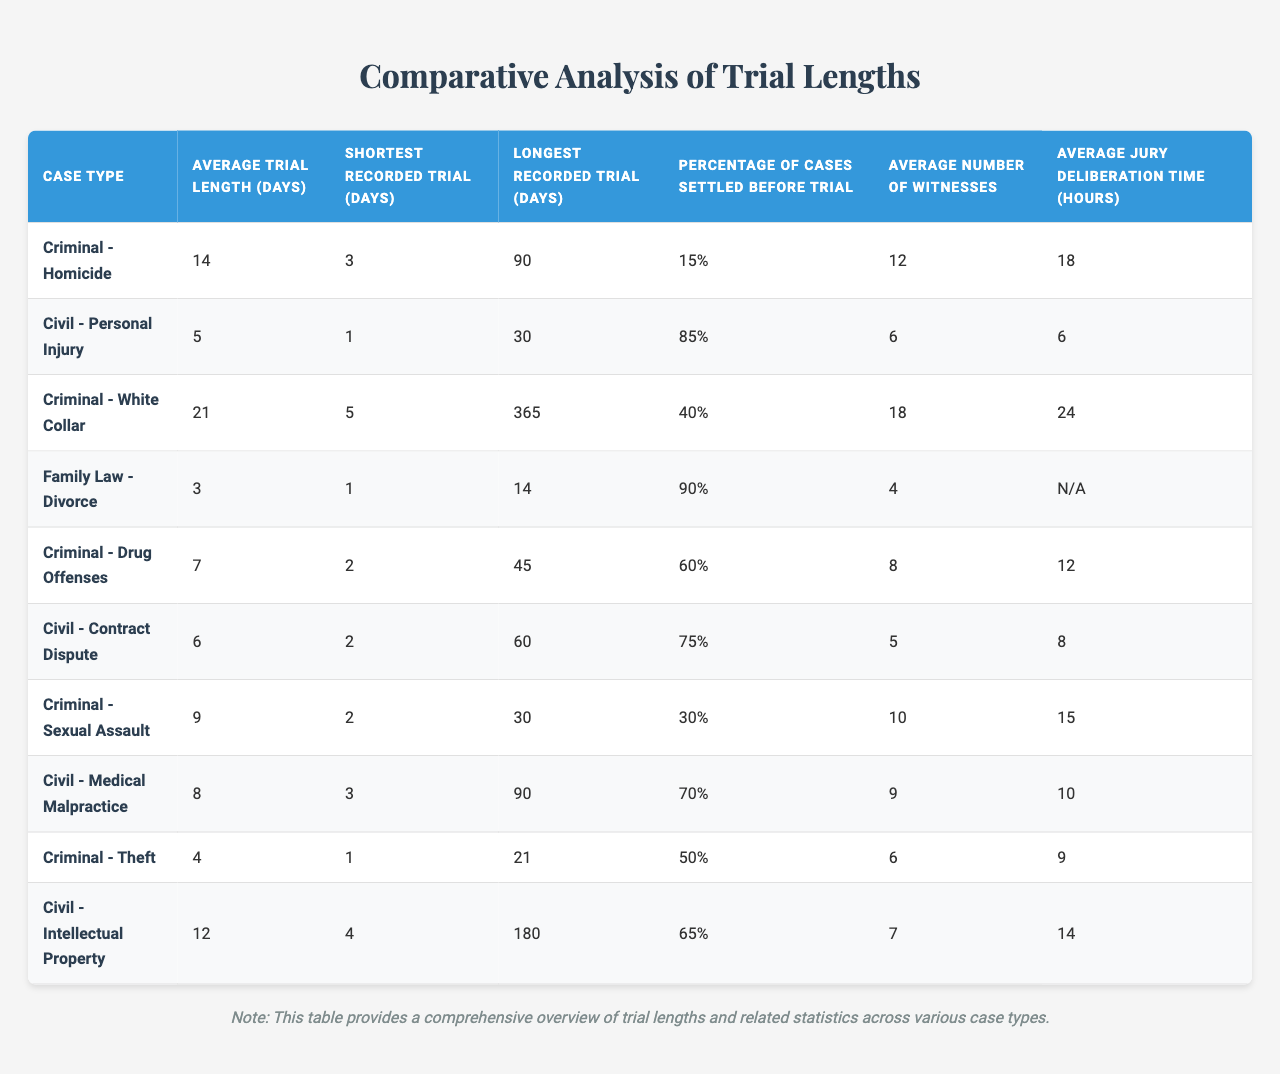What is the average trial length for "Criminal - Homicide" cases? From the table, the average trial length for "Criminal - Homicide" is listed as 14 days.
Answer: 14 days What is the shortest recorded trial for "Civil - Medical Malpractice"? The shortest recorded trial for "Civil - Medical Malpractice" is 3 days, as indicated in the corresponding column of the table.
Answer: 3 days Which case type has the longest recorded trial? The longest recorded trial is 365 days for "Criminal - White Collar," which can be seen in the "Longest Recorded Trial (Days)" column of the table.
Answer: Criminal - White Collar What percentage of "Family Law - Divorce" cases are settled before trial? The table shows that 90% of "Family Law - Divorce" cases are settled before trial, as indicated in the relevant column.
Answer: 90% How many witnesses are, on average, involved in "Criminal - Drug Offenses"? According to the table, the average number of witnesses for "Criminal - Drug Offenses" is 8.
Answer: 8 What is the average jury deliberation time for "Civil - Personal Injury"? The table lists the average jury deliberation time for "Civil - Personal Injury" as 6 hours.
Answer: 6 hours Which case type has the highest percentage of cases settled before trial, and what is that percentage? "Civil - Personal Injury" has the highest percentage at 85%, as per the table's "Percentage of Cases Settled Before Trial."
Answer: Civil - Personal Injury, 85% Calculate the average trial length of all case types listed in the table. The average trial length can be calculated by summing all the average trial lengths (14 + 5 + 21 + 3 + 7 + 6 + 9 + 8 + 4 + 12 = 89), and then dividing by the number of case types (10), which results in an average trial length of 8.9 days.
Answer: 8.9 days Is the average trial length for "Civil - Contract Dispute" longer than 7 days? The average trial length for "Civil - Contract Dispute" is 6 days, which is less than 7 days according to the table.
Answer: No What is the difference in average trial lengths between "Criminal - Sexual Assault" and "Criminal - Theft"? The average trial length for "Criminal - Sexual Assault" is 9 days and for "Criminal - Theft" is 4 days. The difference is 9 - 4 = 5 days.
Answer: 5 days If a case type has an average trial length of 21 days and a jury deliberation time of 24 hours, what case type is it, and is the trial length longer than the deliberation time? The case type with an average trial length of 21 days is "Criminal - White Collar." Since 21 days is longer than 24 hours (1 day), the trial length is indeed longer than the deliberation time.
Answer: Criminal - White Collar, Yes 